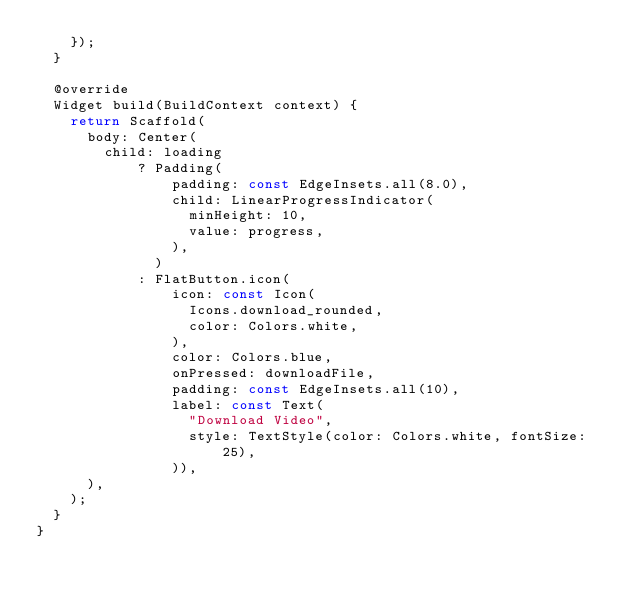Convert code to text. <code><loc_0><loc_0><loc_500><loc_500><_Dart_>    });
  }

  @override
  Widget build(BuildContext context) {
    return Scaffold(
      body: Center(
        child: loading
            ? Padding(
                padding: const EdgeInsets.all(8.0),
                child: LinearProgressIndicator(
                  minHeight: 10,
                  value: progress,
                ),
              )
            : FlatButton.icon(
                icon: const Icon(
                  Icons.download_rounded,
                  color: Colors.white,
                ),
                color: Colors.blue,
                onPressed: downloadFile,
                padding: const EdgeInsets.all(10),
                label: const Text(
                  "Download Video",
                  style: TextStyle(color: Colors.white, fontSize: 25),
                )),
      ),
    );
  }
}
</code> 